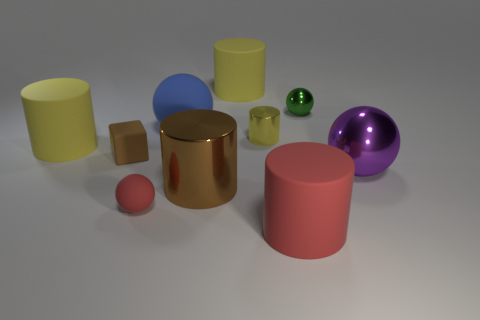The blue thing has what shape?
Ensure brevity in your answer.  Sphere. There is a cylinder that is the same color as the block; what size is it?
Provide a succinct answer. Large. Is the material of the big sphere behind the big purple metal ball the same as the tiny brown block?
Your answer should be very brief. Yes. Are there any tiny rubber blocks of the same color as the large metal cylinder?
Offer a terse response. Yes. There is a tiny red thing that is to the left of the green metallic object; does it have the same shape as the big metal object behind the brown cylinder?
Keep it short and to the point. Yes. Are there any tiny purple spheres made of the same material as the blue sphere?
Your response must be concise. No. What number of red things are either small metal cylinders or small rubber spheres?
Your response must be concise. 1. There is a matte cylinder that is to the right of the tiny red sphere and behind the block; how big is it?
Your response must be concise. Large. Is the number of blue matte objects in front of the small green metal sphere greater than the number of small yellow things?
Give a very brief answer. No. What number of cylinders are large blue matte things or small cyan things?
Your answer should be compact. 0. 